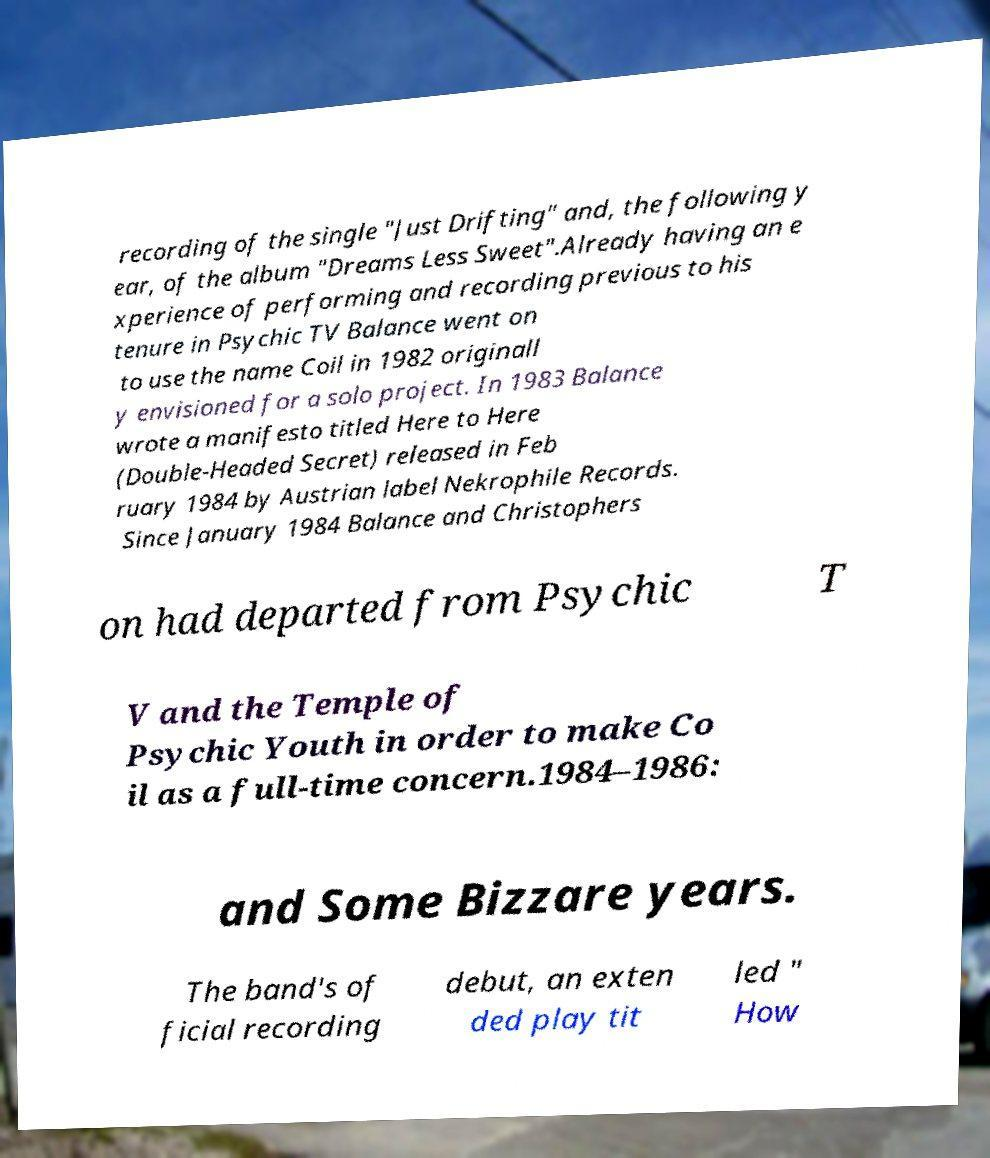Please identify and transcribe the text found in this image. recording of the single "Just Drifting" and, the following y ear, of the album "Dreams Less Sweet".Already having an e xperience of performing and recording previous to his tenure in Psychic TV Balance went on to use the name Coil in 1982 originall y envisioned for a solo project. In 1983 Balance wrote a manifesto titled Here to Here (Double-Headed Secret) released in Feb ruary 1984 by Austrian label Nekrophile Records. Since January 1984 Balance and Christophers on had departed from Psychic T V and the Temple of Psychic Youth in order to make Co il as a full-time concern.1984–1986: and Some Bizzare years. The band's of ficial recording debut, an exten ded play tit led " How 